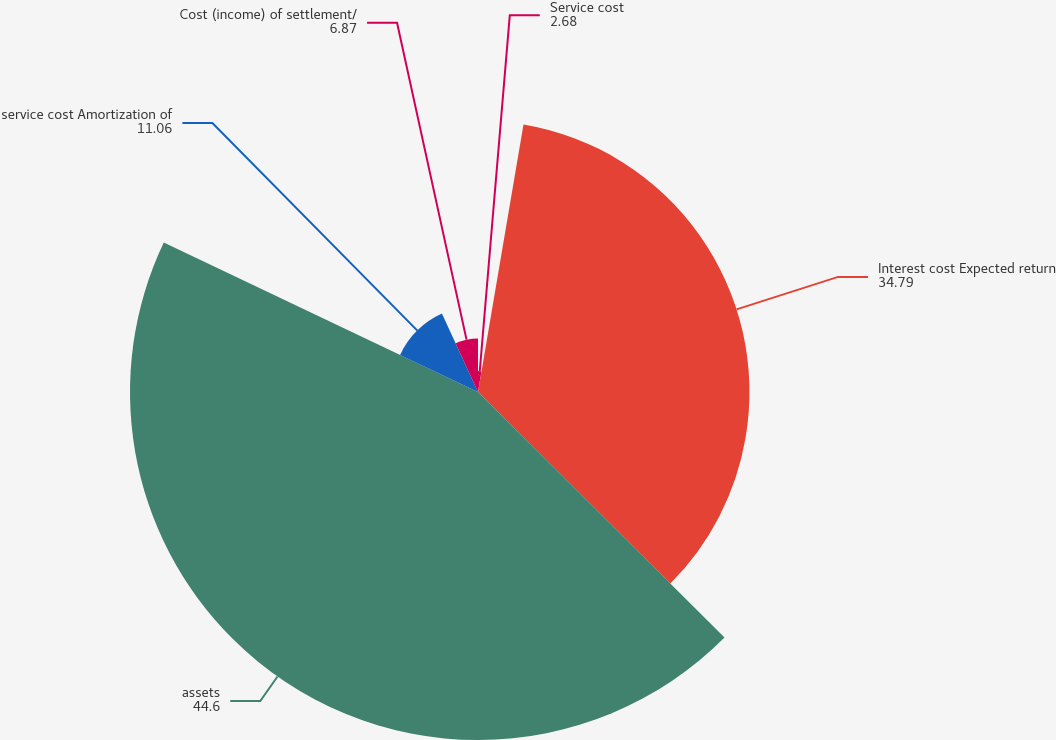<chart> <loc_0><loc_0><loc_500><loc_500><pie_chart><fcel>Service cost<fcel>Interest cost Expected return<fcel>assets<fcel>service cost Amortization of<fcel>Cost (income) of settlement/<nl><fcel>2.68%<fcel>34.79%<fcel>44.6%<fcel>11.06%<fcel>6.87%<nl></chart> 